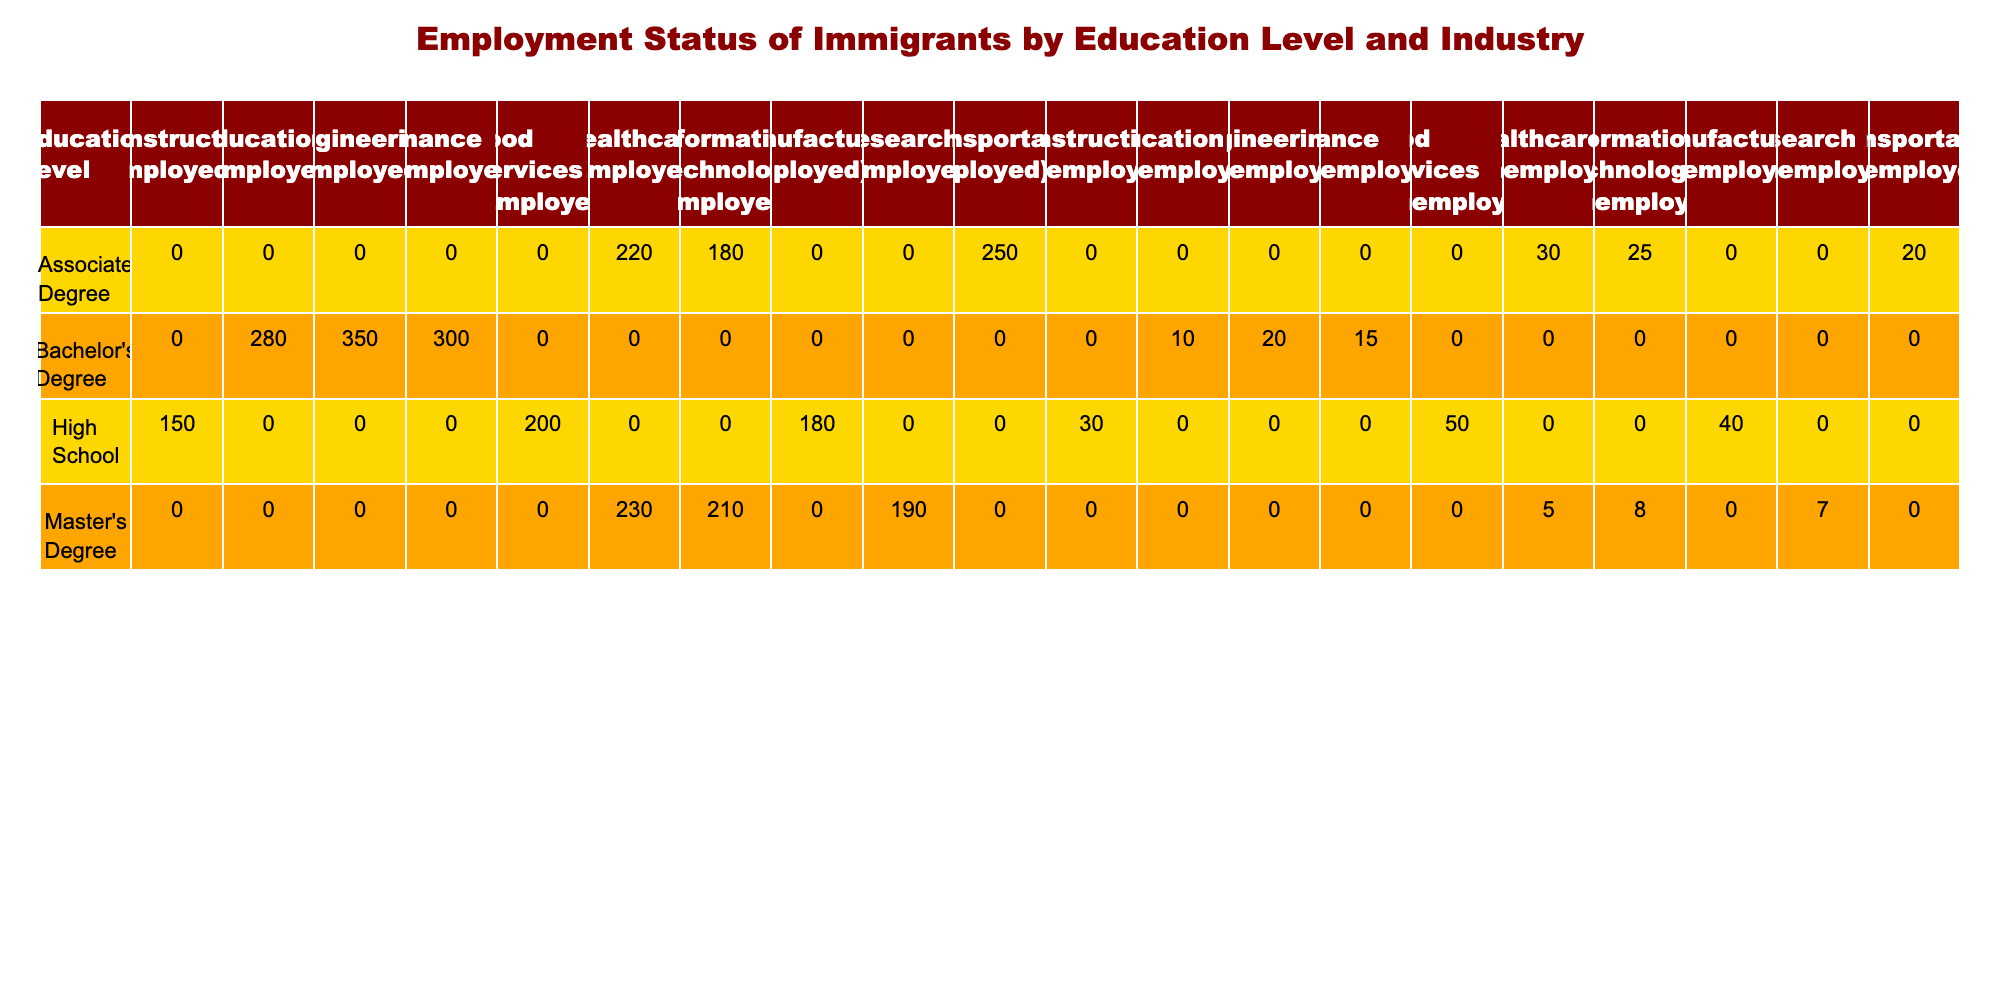What is the total number of employed individuals with a Bachelor's degree? From the table, under the Bachelor's Degree row, the employed count for Finance is 300, for Education is 280, and for Engineering is 350. Adding these together gives us 300 + 280 + 350 = 930 employed individuals with a Bachelor's degree.
Answer: 930 In which industry do the immigrants with an Associate Degree have the highest employment? The table shows the following employed counts for individuals with an Associate Degree: Transportation 250, Healthcare 220, and Information Technology 180. The highest number is in the Transportation industry with 250 employed individuals.
Answer: Transportation Is the number of unemployed individuals with a Master's Degree in Healthcare greater than those in Information Technology? The table shows 5 unemployed individuals with a Master's Degree in Healthcare and 8 in Information Technology. Since 5 is less than 8, the statement is false.
Answer: No What is the total number of unemployed individuals across all educational levels in the Food Services industry? The table indicates that there are 50 unemployed individuals with a High School education in the Food Services industry. There are no other educational levels reported for Food Services, thus making the total 50 unemployed in this industry.
Answer: 50 Calculate the average number of unemployed individuals per education level in the Construction industry. There is only one education level reported for the Construction industry, which is High School, with 30 unemployed individuals. Since there are no other data points to average, the average is simply the same as the number of unemployed, thus 30.
Answer: 30 Which education level has the lowest total unemployment across all industries? To determine this, we need to calculate the total unemployed for each education level. High School has 30 + 50 + 40 = 120, Associate Degree has 20 + 30 + 25 = 75, Bachelor's Degree has 15 + 10 + 20 = 45, and Master's Degree has 5 + 8 + 7 = 20. The lowest unemployment total across all industries is for the Master's Degree with 20 unemployed individuals.
Answer: Master's Degree Are there more employed individuals in the Manufacturing industry than in the Transportation industry among immigrants with an Associate Degree? The table indicates that there are 180 employed individuals in Manufacturing and 250 in Transportation. Since 180 is less than 250, the statement is false.
Answer: No What is the difference in the number of employed individuals between those with a Bachelor's Degree in Engineering and those with a Master's Degree in Research? The table shows that there are 350 employed individuals with a Bachelor's Degree in Engineering and 190 with a Master's Degree in Research. The difference is 350 - 190 = 160 employed individuals.
Answer: 160 